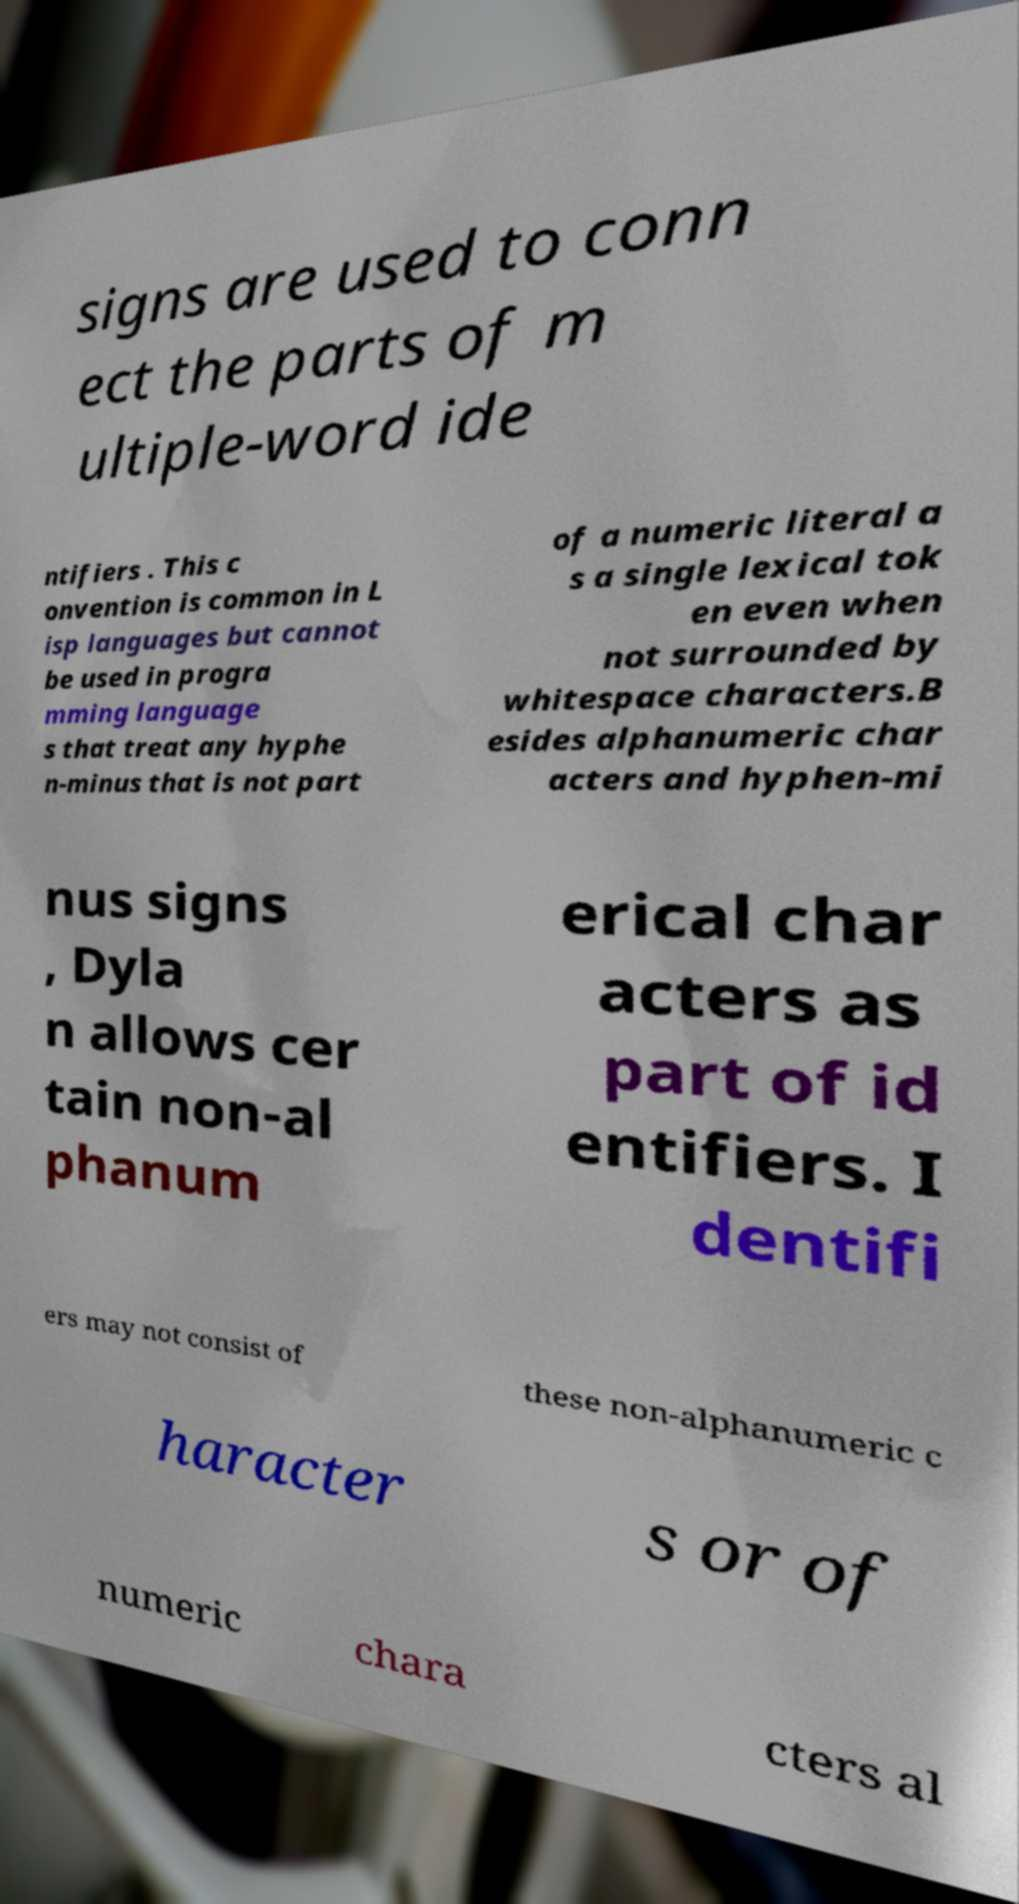I need the written content from this picture converted into text. Can you do that? signs are used to conn ect the parts of m ultiple-word ide ntifiers . This c onvention is common in L isp languages but cannot be used in progra mming language s that treat any hyphe n-minus that is not part of a numeric literal a s a single lexical tok en even when not surrounded by whitespace characters.B esides alphanumeric char acters and hyphen-mi nus signs , Dyla n allows cer tain non-al phanum erical char acters as part of id entifiers. I dentifi ers may not consist of these non-alphanumeric c haracter s or of numeric chara cters al 